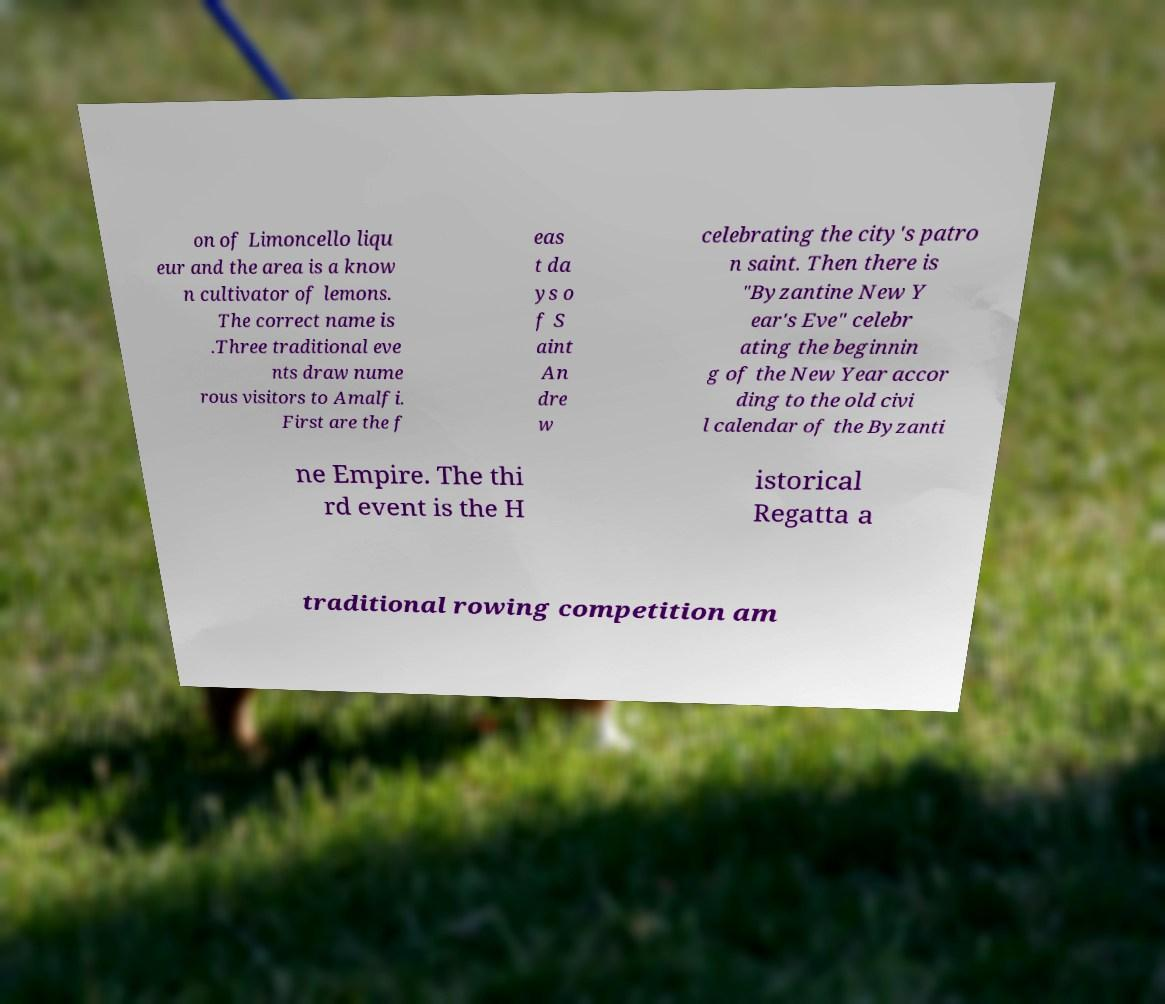What messages or text are displayed in this image? I need them in a readable, typed format. on of Limoncello liqu eur and the area is a know n cultivator of lemons. The correct name is .Three traditional eve nts draw nume rous visitors to Amalfi. First are the f eas t da ys o f S aint An dre w celebrating the city's patro n saint. Then there is "Byzantine New Y ear's Eve" celebr ating the beginnin g of the New Year accor ding to the old civi l calendar of the Byzanti ne Empire. The thi rd event is the H istorical Regatta a traditional rowing competition am 